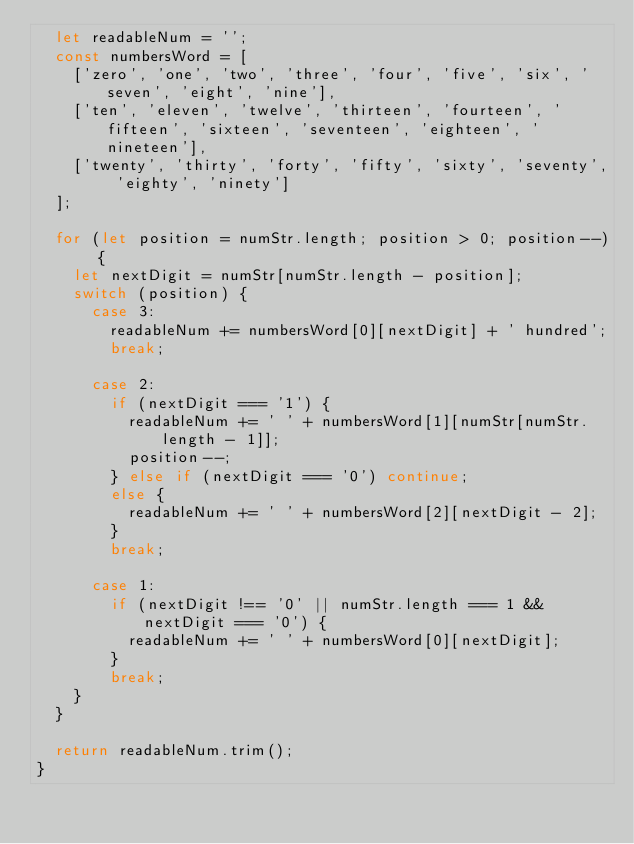<code> <loc_0><loc_0><loc_500><loc_500><_JavaScript_>  let readableNum = '';
  const numbersWord = [
    ['zero', 'one', 'two', 'three', 'four', 'five', 'six', 'seven', 'eight', 'nine'],
    ['ten', 'eleven', 'twelve', 'thirteen', 'fourteen', 'fifteen', 'sixteen', 'seventeen', 'eighteen', 'nineteen'],
    ['twenty', 'thirty', 'forty', 'fifty', 'sixty', 'seventy', 'eighty', 'ninety']
  ];

  for (let position = numStr.length; position > 0; position--) {
    let nextDigit = numStr[numStr.length - position];
    switch (position) {
      case 3:
        readableNum += numbersWord[0][nextDigit] + ' hundred';
        break;

      case 2:
        if (nextDigit === '1') {
          readableNum += ' ' + numbersWord[1][numStr[numStr.length - 1]];
          position--;
        } else if (nextDigit === '0') continue;
        else {
          readableNum += ' ' + numbersWord[2][nextDigit - 2];
        }
        break;

      case 1:
        if (nextDigit !== '0' || numStr.length === 1 && nextDigit === '0') {
          readableNum += ' ' + numbersWord[0][nextDigit];
        }
        break;
    }
  }

  return readableNum.trim();
}
</code> 